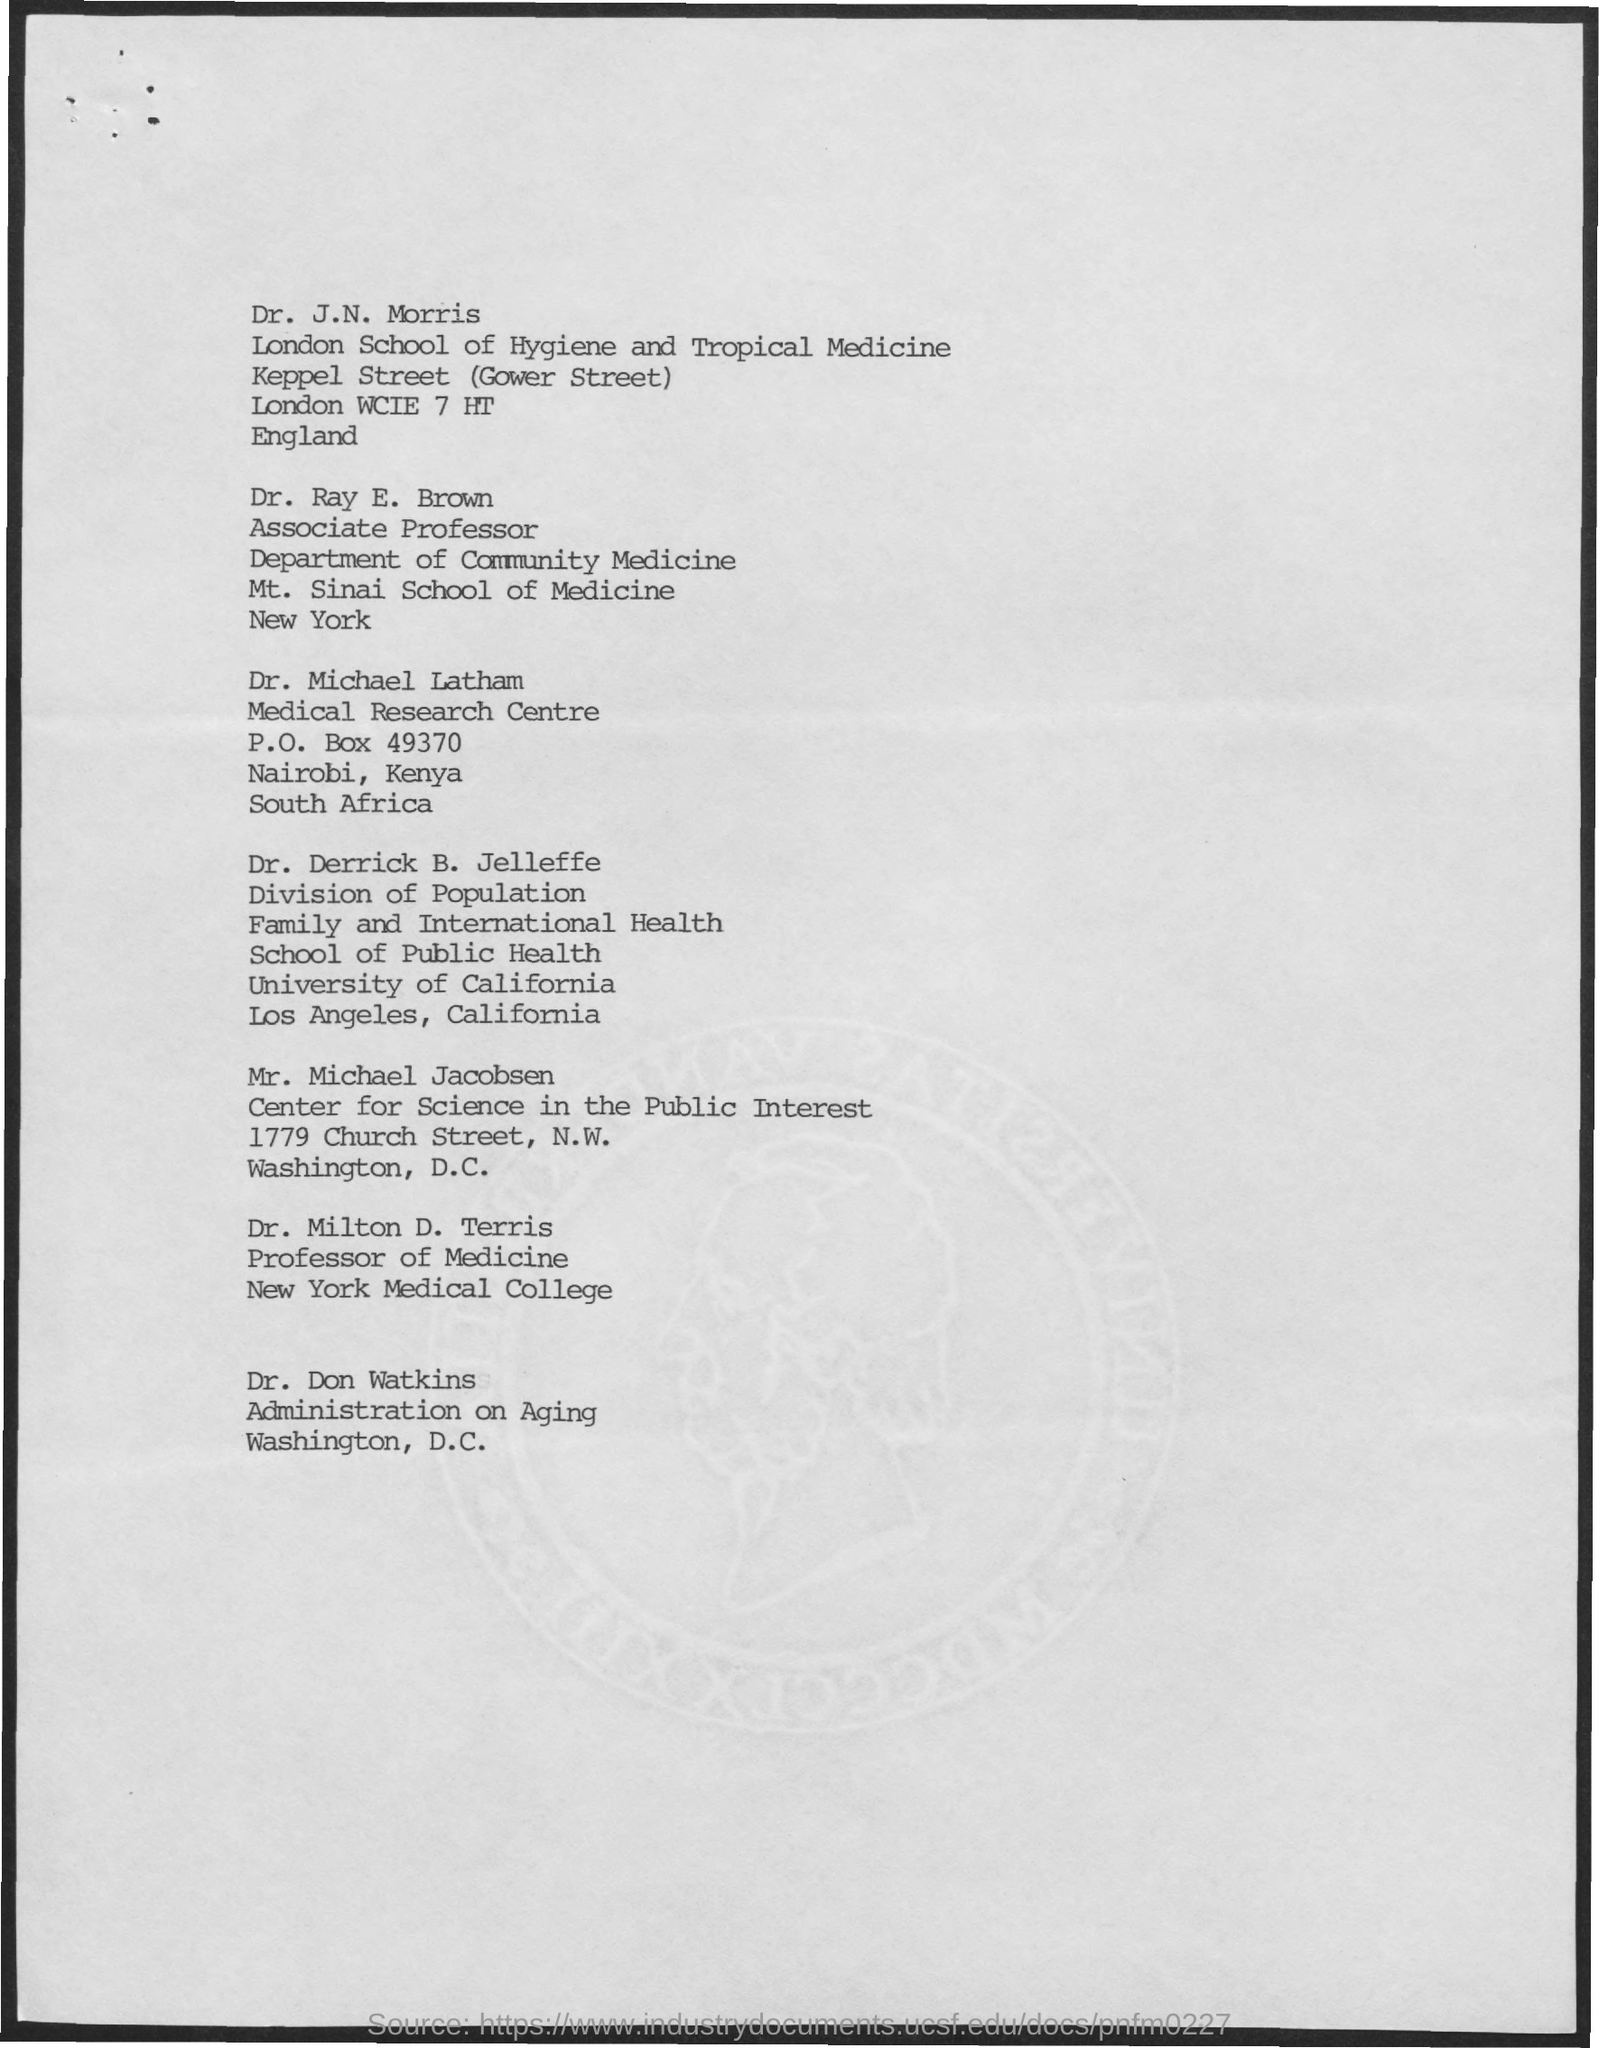Point out several critical features in this image. Dr. Ray E. Brown is affiliated with the Department of Community Medicine. Dr. Ray E. Brown holds the designation of an associate professor. 